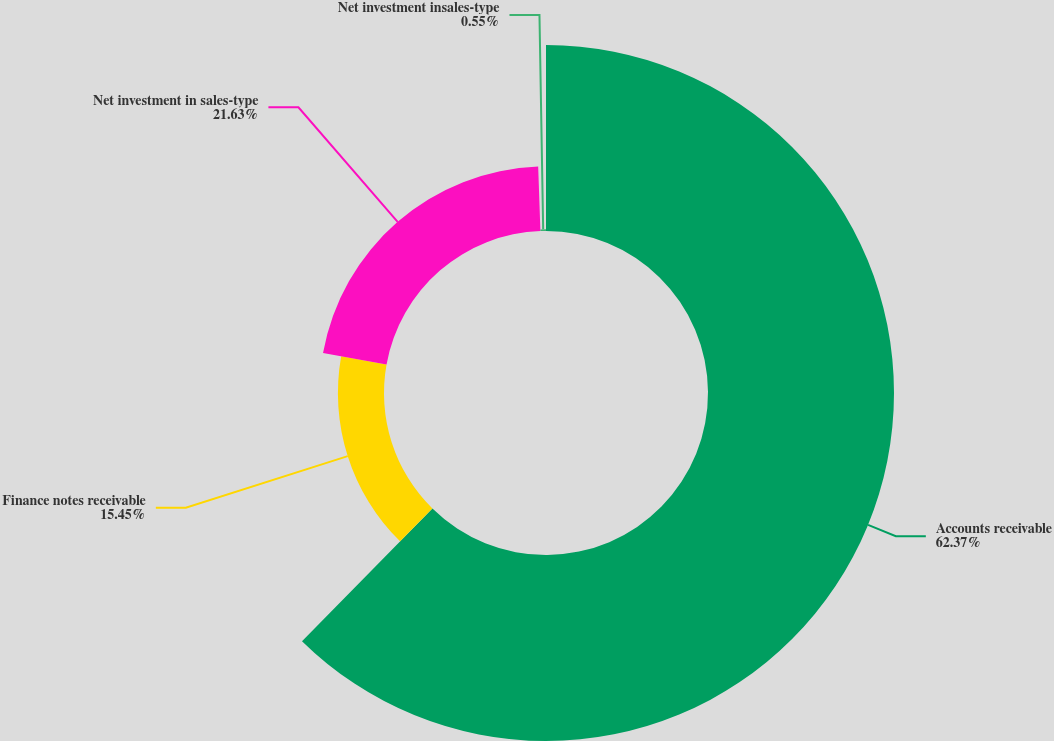Convert chart to OTSL. <chart><loc_0><loc_0><loc_500><loc_500><pie_chart><fcel>Accounts receivable<fcel>Finance notes receivable<fcel>Net investment in sales-type<fcel>Net investment insales-type<nl><fcel>62.36%<fcel>15.45%<fcel>21.63%<fcel>0.55%<nl></chart> 